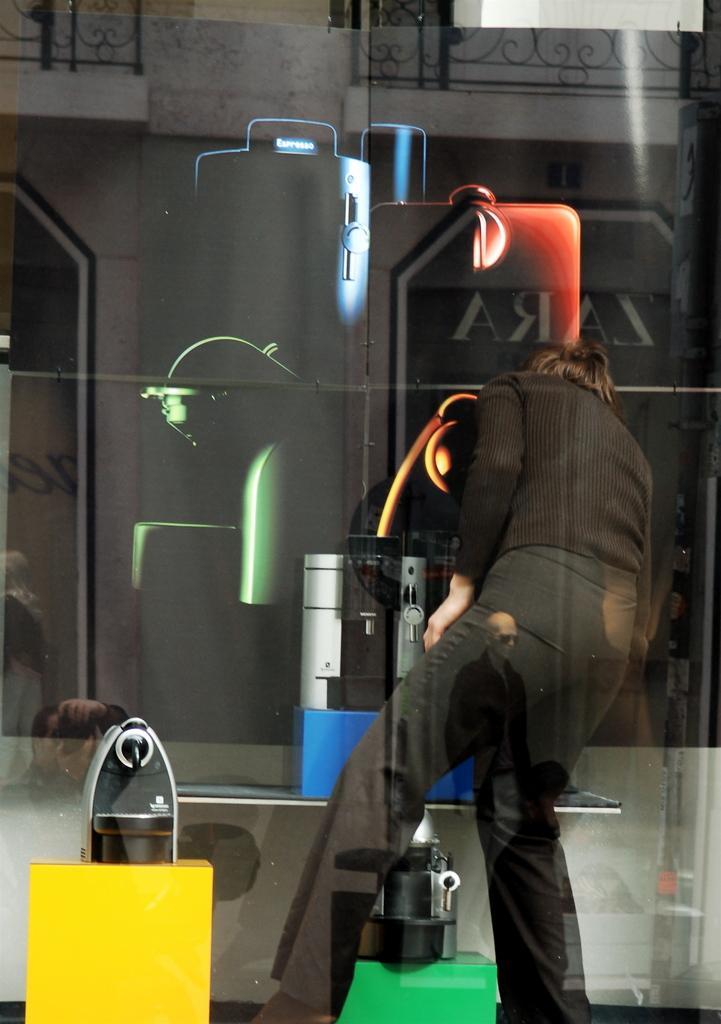Describe this image in one or two sentences. In this image we can see a glass through which we can see a person wearing black dress is stunning. Here we can see the reflection of a person holding a camera and the building. 